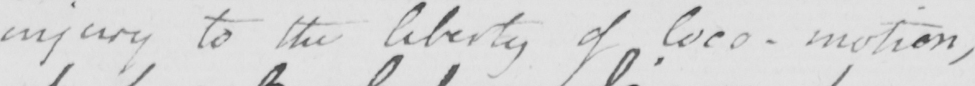Transcribe the text shown in this historical manuscript line. injury to the liberty of loco-motion , 